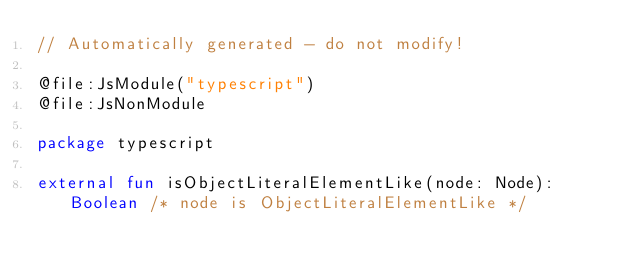<code> <loc_0><loc_0><loc_500><loc_500><_Kotlin_>// Automatically generated - do not modify!

@file:JsModule("typescript")
@file:JsNonModule

package typescript

external fun isObjectLiteralElementLike(node: Node): Boolean /* node is ObjectLiteralElementLike */
</code> 